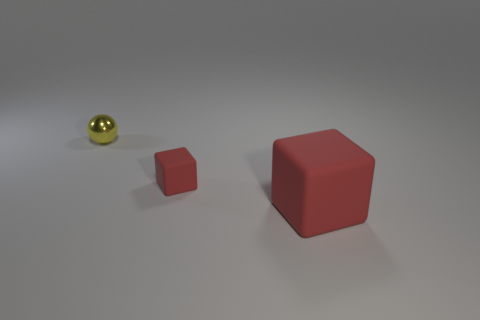Is the light source in this scene coming from a specific direction? Yes, it appears that the light source is coming from above, slightly to the left. This is indicated by the shadows being cast directly opposite to it on the ground. What time of day does the lighting suggest if this were an outdoor scene? If this were outdoors, the angle and softness of the shadows could suggest either morning or late afternoon. However, the lack of environmental cues like a sky or landscape elements makes it difficult to accurately determine the time of day. 